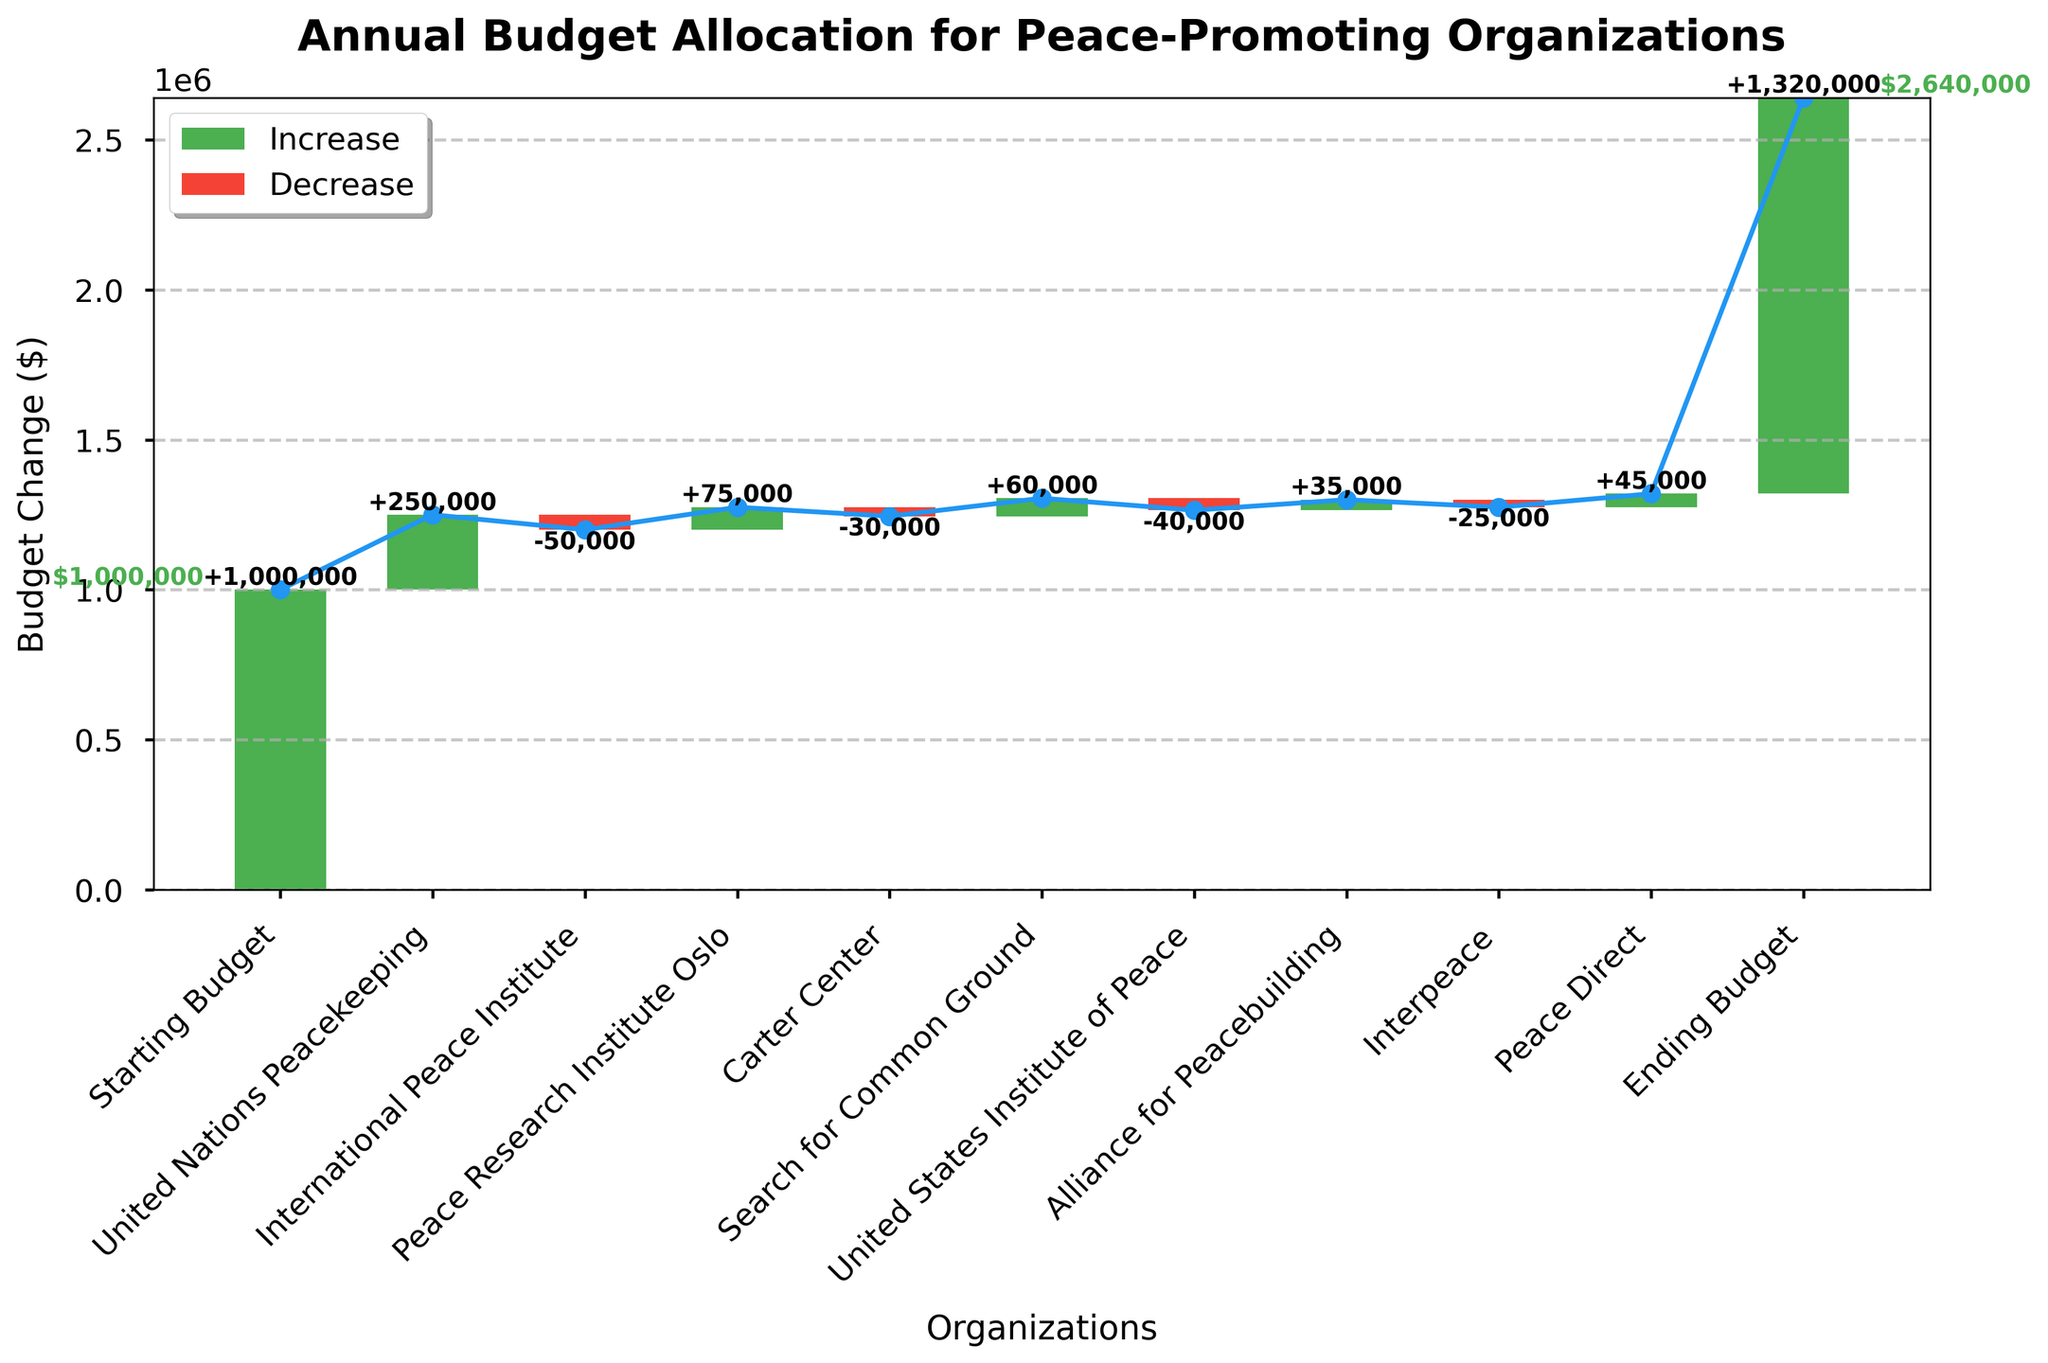What is the title of the chart? The title of the chart is located at the top of the figure, and it provides a summary of what the data visualizes. The title reads "Annual Budget Allocation for Peace-Promoting Organizations."
Answer: Annual Budget Allocation for Peace-Promoting Organizations How many organizations had a positive change in budget allocation? By observing the bars in the chart, count the number of green bars indicating a positive budget change. The organizations with green bars are United Nations Peacekeeping, Peace Research Institute Oslo, Search for Common Ground, Alliance for Peacebuilding, and Peace Direct, totaling 5 organizations.
Answer: 5 What is the budget change for the United Nations Peacekeeping? Look for the bar representing the "United Nations Peacekeeping" category. The label on this bar shows a positive change of +250,000.
Answer: +250,000 Which organization had the largest budget decrease? Compare the red bars that represent budget decreases. The largest negative value is for the International Peace Institute with a change of -50,000.
Answer: International Peace Institute What is the starting budget? The starting budget is located at the beginning of the chart, and it's labeled "Starting Budget," which shows a value of 1,000,000.
Answer: 1,000,000 What is the ending budget? The ending budget is located at the end of the chart, and it's labeled "Ending Budget," which shows a value of 1,320,000.
Answer: 1,320,000 How much did the Carter Center's budget change? Locate the bar for the "Carter Center." The label on this bar indicates a budget change of -30,000.
Answer: -30,000 Which organizations had a budget decrease? Identify the red bars representing budget decreases. These bars belong to the International Peace Institute, Carter Center, United States Institute of Peace, and Interpeace.
Answer: International Peace Institute, Carter Center, United States Institute of Peace, Interpeace What is the cumulative budget change after including Peace Research Institute Oslo? Start with the initial budget of 1,000,000. Add the cumulative changes up to the Peace Research Institute Oslo: +250,000 (United Nations Peacekeeping) - 50,000 (International Peace Institute) + 75,000 (Peace Research Institute Oslo). The cumulative budget after these changes is 1,000,000 + 250,000 - 50,000 + 75,000 = 1,275,000.
Answer: 1,275,000 How does the contribution of Search for Common Ground compare to Interpeace? The bar for "Search for Common Ground" shows a positive change of +60,000, while "Interpeace" shows a negative change of -25,000. The difference between them is 60,000 - (-25,000) = 85,000.
Answer: 85,000 